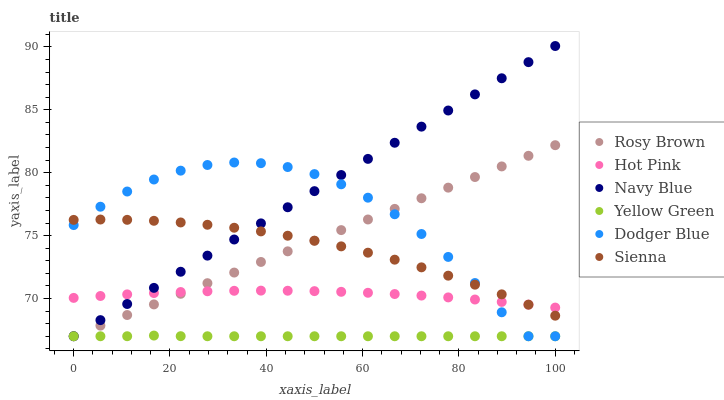Does Yellow Green have the minimum area under the curve?
Answer yes or no. Yes. Does Navy Blue have the maximum area under the curve?
Answer yes or no. Yes. Does Navy Blue have the minimum area under the curve?
Answer yes or no. No. Does Yellow Green have the maximum area under the curve?
Answer yes or no. No. Is Rosy Brown the smoothest?
Answer yes or no. Yes. Is Dodger Blue the roughest?
Answer yes or no. Yes. Is Yellow Green the smoothest?
Answer yes or no. No. Is Yellow Green the roughest?
Answer yes or no. No. Does Yellow Green have the lowest value?
Answer yes or no. Yes. Does Sienna have the lowest value?
Answer yes or no. No. Does Navy Blue have the highest value?
Answer yes or no. Yes. Does Yellow Green have the highest value?
Answer yes or no. No. Is Yellow Green less than Hot Pink?
Answer yes or no. Yes. Is Hot Pink greater than Yellow Green?
Answer yes or no. Yes. Does Hot Pink intersect Dodger Blue?
Answer yes or no. Yes. Is Hot Pink less than Dodger Blue?
Answer yes or no. No. Is Hot Pink greater than Dodger Blue?
Answer yes or no. No. Does Yellow Green intersect Hot Pink?
Answer yes or no. No. 